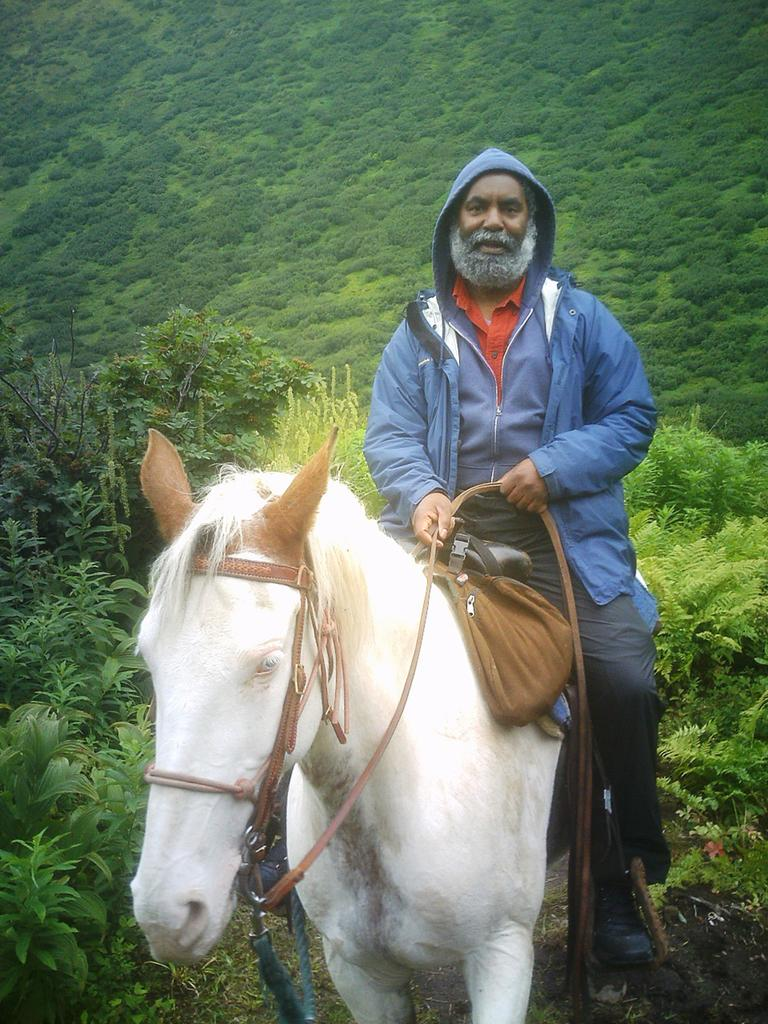What type of vegetation is present in the image? There are trees and grass in the image. What is the man in the image doing? The man is sitting on a white-colored horse in the image. What type of angle is the orange being cut at in the image? There is no orange present in the image, so it is not possible to answer a question about cutting an orange. 